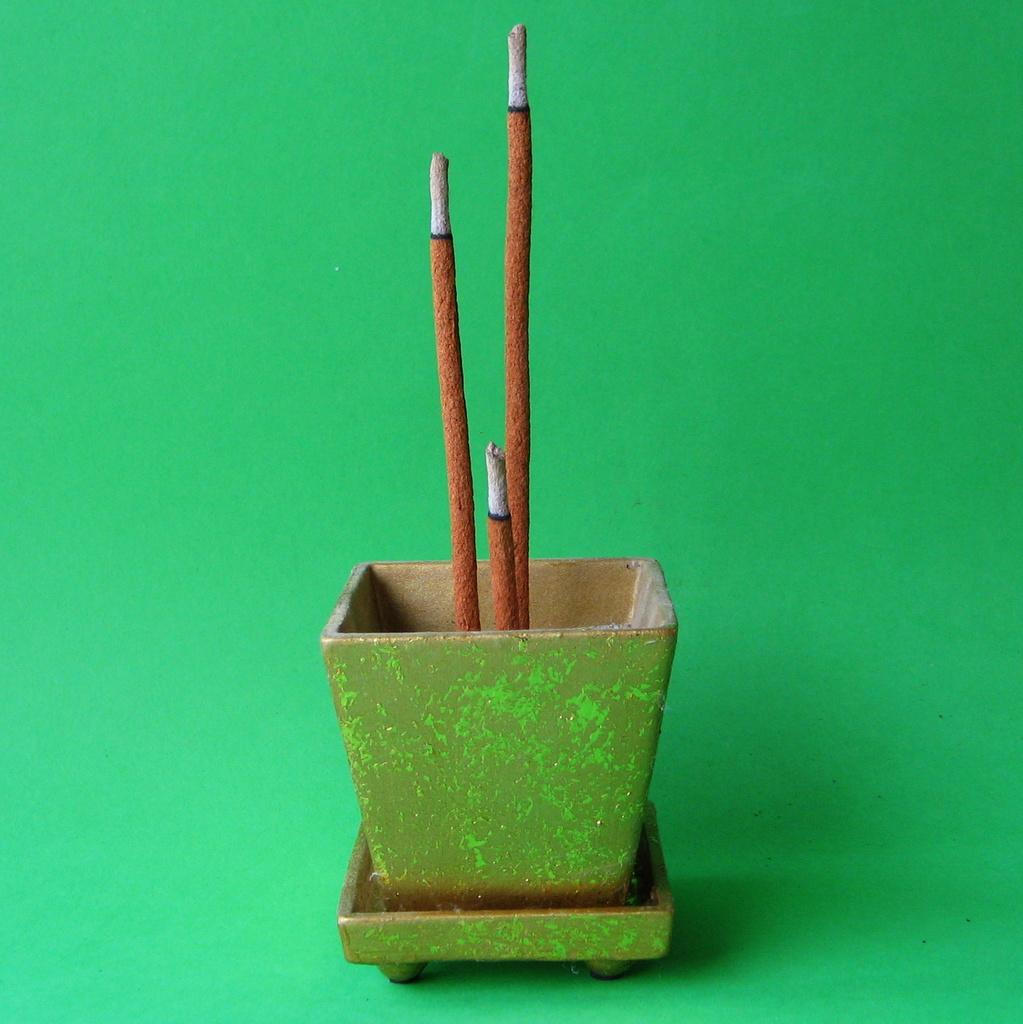What is the main object in the image? There is a pot in the image. What is inside the pot? There are brown and grey color sticks in the pot. What color is the background of the image? The background of the image is green. What is the average income of the group in the image? There is no group or income information present in the image; it only features a pot with color sticks and a green background. 